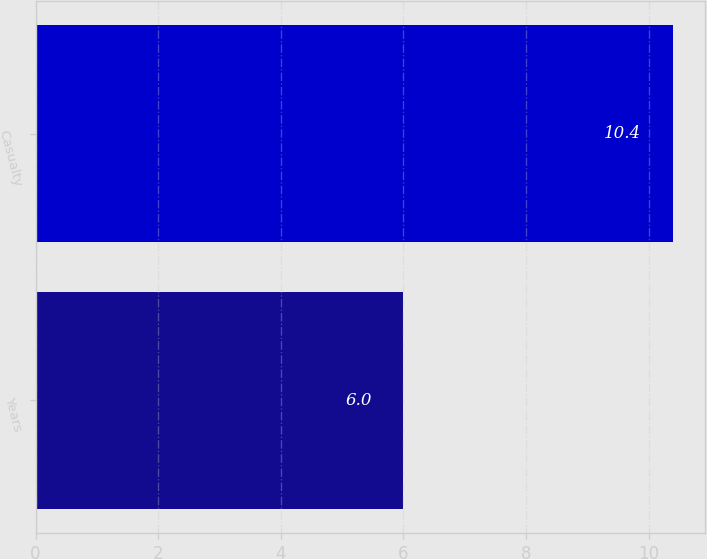Convert chart. <chart><loc_0><loc_0><loc_500><loc_500><bar_chart><fcel>Years<fcel>Casualty<nl><fcel>6<fcel>10.4<nl></chart> 